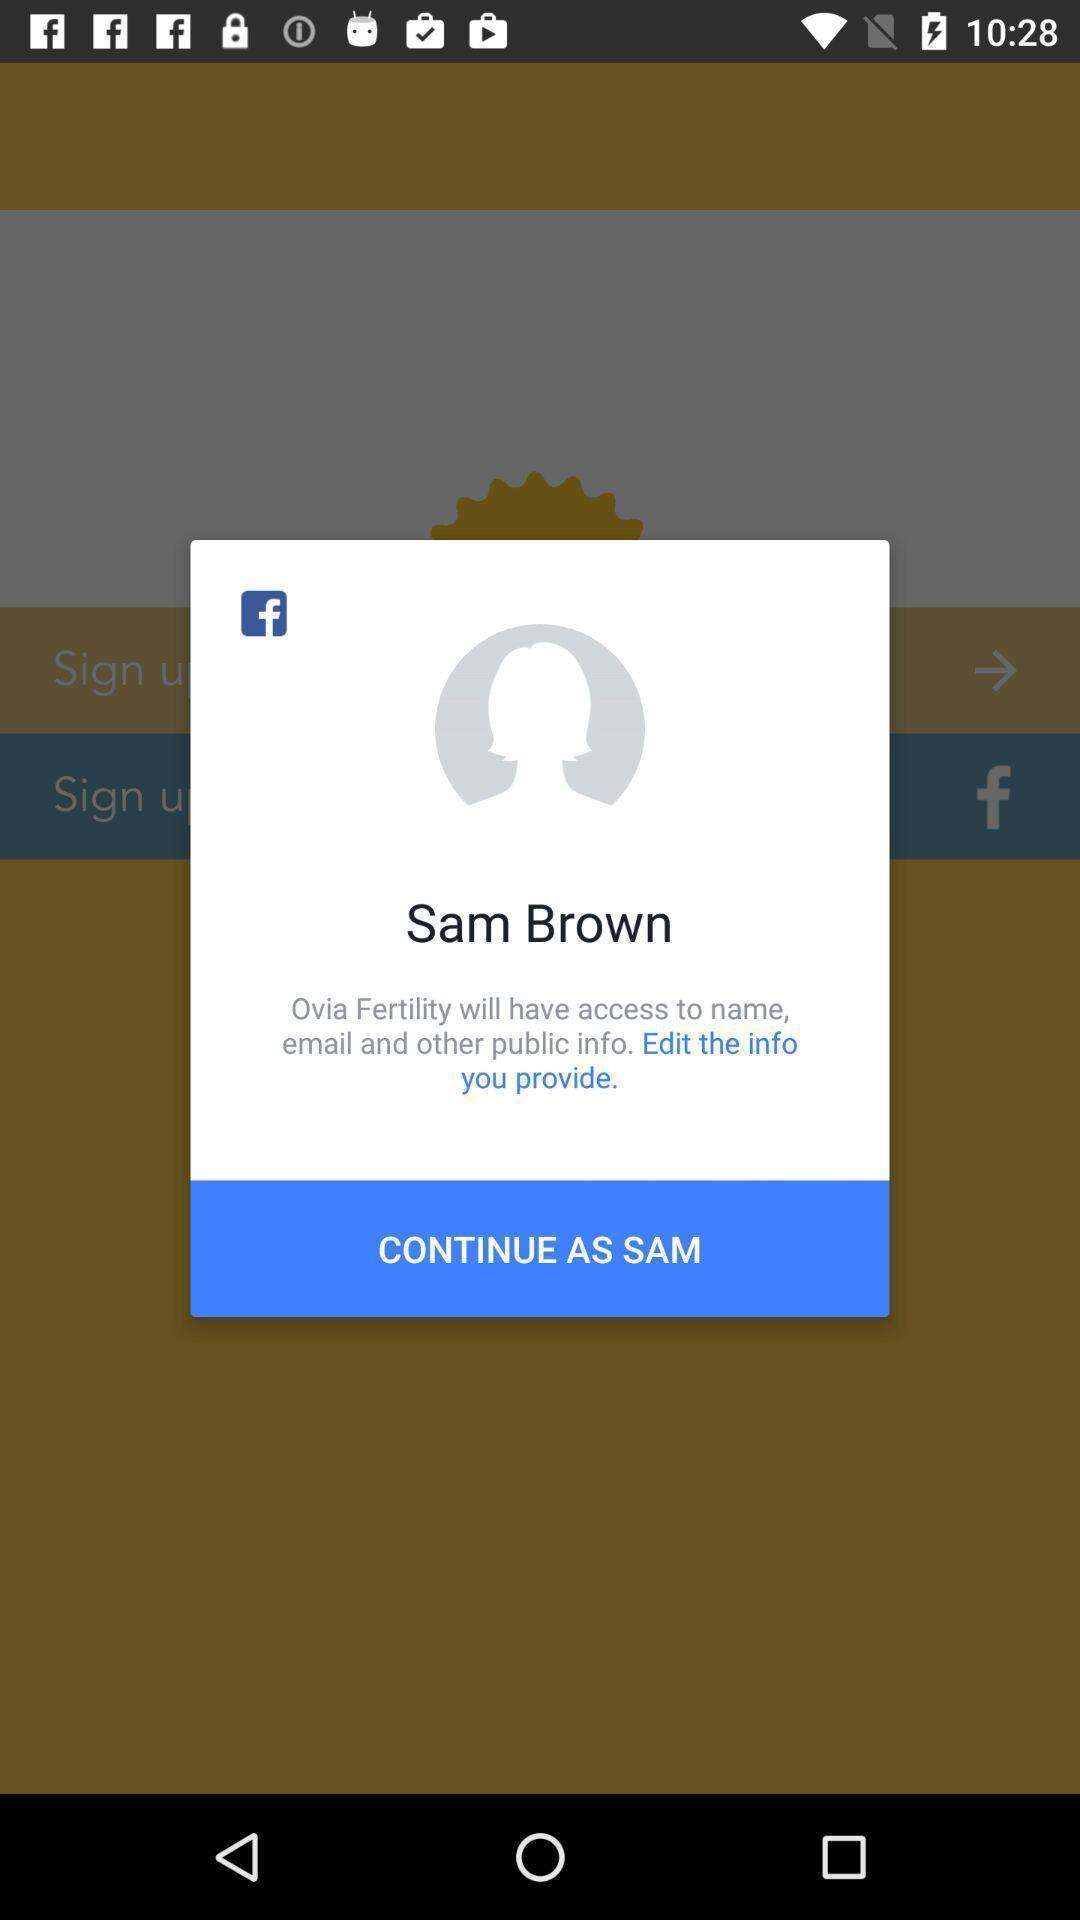What is the overall content of this screenshot? Pop-up displaying to continue in app. 